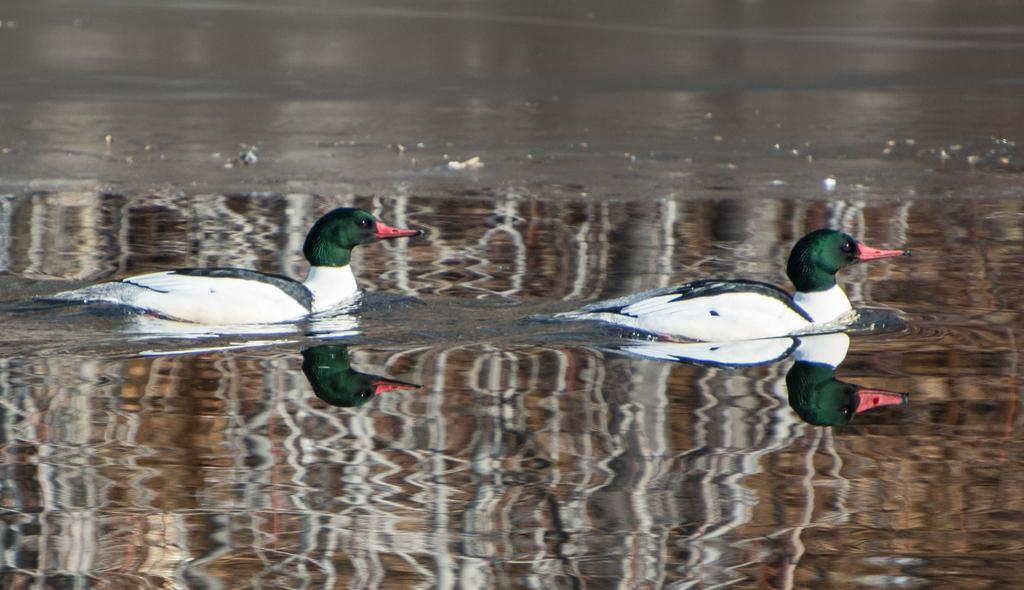How many ducks are present in the image? There are 2 ducks in the image. What colors are the ducks? The ducks are in white and green. What are the ducks doing in the image? The ducks are swimming in water. What is the feeling of the ducks towards their aunt in the image? There is no mention of an aunt or any feelings in the image; it only features 2 ducks swimming in water. 